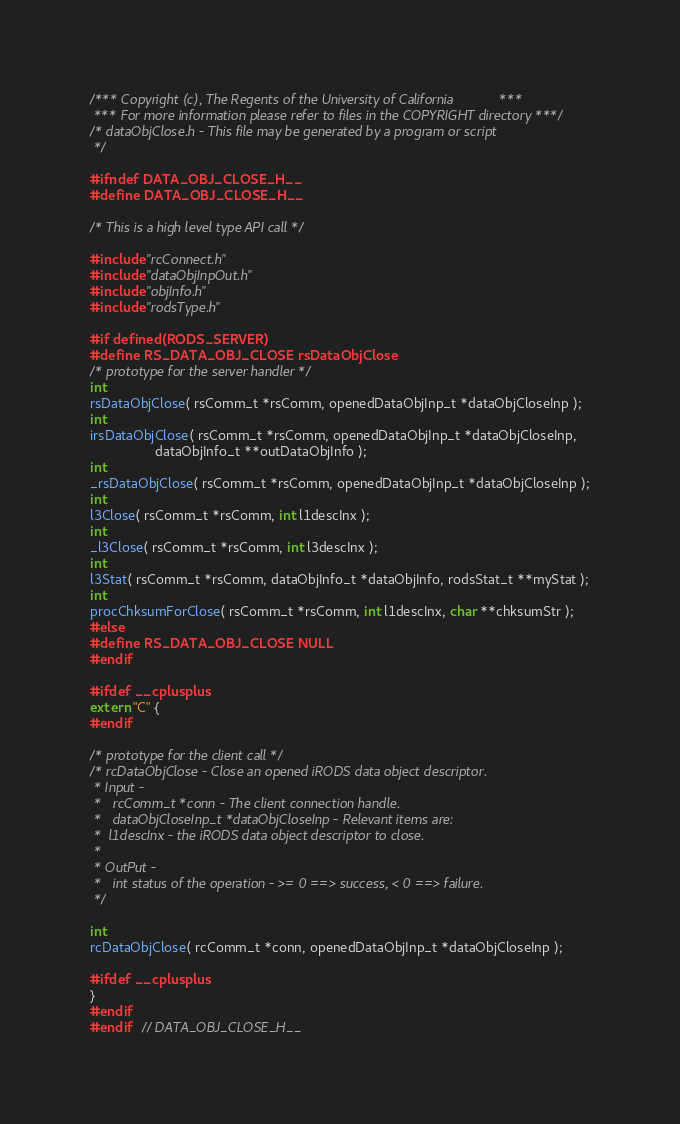Convert code to text. <code><loc_0><loc_0><loc_500><loc_500><_C_>/*** Copyright (c), The Regents of the University of California            ***
 *** For more information please refer to files in the COPYRIGHT directory ***/
/* dataObjClose.h - This file may be generated by a program or script
 */

#ifndef DATA_OBJ_CLOSE_H__
#define DATA_OBJ_CLOSE_H__

/* This is a high level type API call */

#include "rcConnect.h"
#include "dataObjInpOut.h"
#include "objInfo.h"
#include "rodsType.h"

#if defined(RODS_SERVER)
#define RS_DATA_OBJ_CLOSE rsDataObjClose
/* prototype for the server handler */
int
rsDataObjClose( rsComm_t *rsComm, openedDataObjInp_t *dataObjCloseInp );
int
irsDataObjClose( rsComm_t *rsComm, openedDataObjInp_t *dataObjCloseInp,
                 dataObjInfo_t **outDataObjInfo );
int
_rsDataObjClose( rsComm_t *rsComm, openedDataObjInp_t *dataObjCloseInp );
int
l3Close( rsComm_t *rsComm, int l1descInx );
int
_l3Close( rsComm_t *rsComm, int l3descInx );
int
l3Stat( rsComm_t *rsComm, dataObjInfo_t *dataObjInfo, rodsStat_t **myStat );
int
procChksumForClose( rsComm_t *rsComm, int l1descInx, char **chksumStr );
#else
#define RS_DATA_OBJ_CLOSE NULL
#endif

#ifdef __cplusplus
extern "C" {
#endif

/* prototype for the client call */
/* rcDataObjClose - Close an opened iRODS data object descriptor.
 * Input -
 *   rcComm_t *conn - The client connection handle.
 *   dataObjCloseInp_t *dataObjCloseInp - Relevant items are:
 *	l1descInx - the iRODS data object descriptor to close.
 *
 * OutPut -
 *   int status of the operation - >= 0 ==> success, < 0 ==> failure.
 */

int
rcDataObjClose( rcComm_t *conn, openedDataObjInp_t *dataObjCloseInp );

#ifdef __cplusplus
}
#endif
#endif	// DATA_OBJ_CLOSE_H__
</code> 